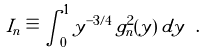<formula> <loc_0><loc_0><loc_500><loc_500>I _ { n } \equiv \int _ { 0 } ^ { 1 } y ^ { - 3 / 4 } \, g _ { n } ^ { 2 } ( y ) \, d y \ .</formula> 